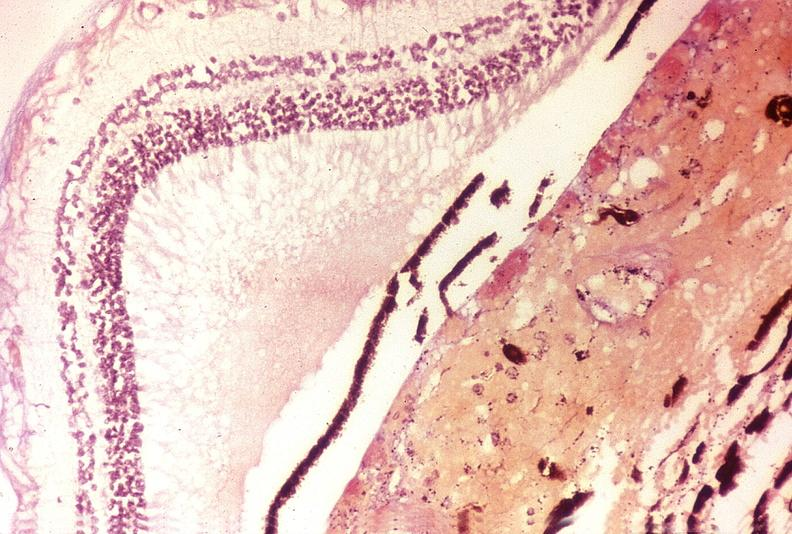does lymphangiomatosis generalized show disseminated intravascular coagulation dic?
Answer the question using a single word or phrase. No 